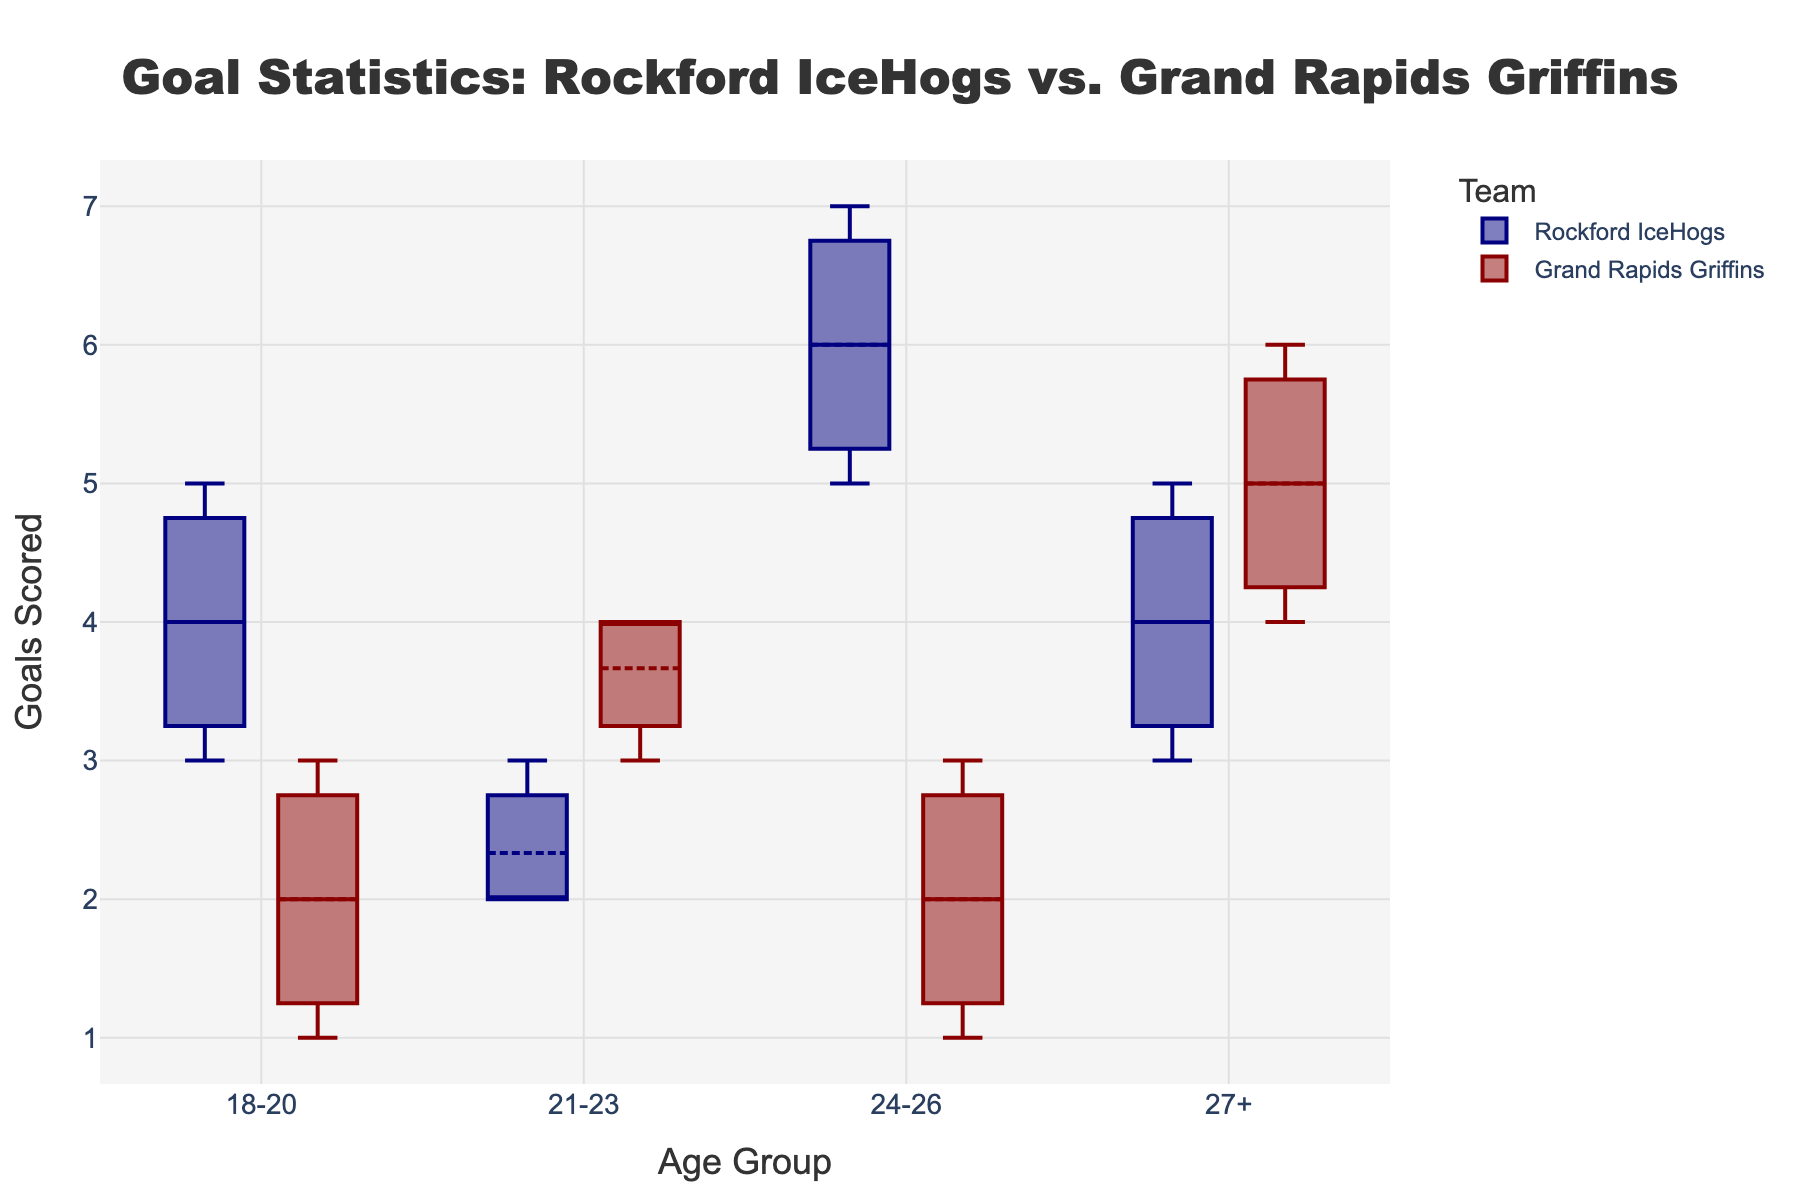What's the title of the figure? The title of the figure is written in a larger font at the top center of the plot.
Answer: Goal Statistics: Rockford IceHogs vs. Grand Rapids Griffins What age groups are shown on the x-axis? The x-axis labels display the different age groups compared.
Answer: 18-20, 21-23, 24-26, 27+ What is the color used to represent Rockford IceHogs' data points? The Rockford IceHogs' data is represented by a specific color in the plot.
Answer: Blue Which age group scored the most goals for Rockford IceHogs? By comparing the median values, we can determine which age group has the highest goal score. The age group 24-26 has the highest median.
Answer: 24-26 How does the median number of goals for the 21-23 age group compare between the two teams? Compare the median line inside the box for the 21-23 age group of both teams. The Rockford IceHogs’ median is below the middle while Grand Rapids Griffins' median is at the center of the boxplot.
Answer: Grand Rapids Griffins have a higher median Which team has more consistent goal-scoring (less variability) in the 18-20 age group? Consistency is shown by the spread of the box in the box plot. A smaller box indicates less variability. The Rockford IceHogs' boxplot for the 18-20 age group is tighter.
Answer: Rockford IceHogs Is there an outlier in the goals scored by any age group? Outliers are often displayed as individual points outside the main box in box plots. We can scan the plot for any such points for all age groups and both teams.
Answer: No outliers Which team has a higher median goal count for the 27+ age group? The median line in the box indicates the median value. For the 27+ age group, the Grand Rapids Griffins have a higher median line compared to the Rockford IceHogs.
Answer: Grand Rapids Griffins What is the interquartile range (IQR) for the 24-26 age group of Rockford IceHogs? The IQR is the range between the first quartile (Q1) and the third quartile (Q3). Calculate IQR by finding the lengths between Q1 and Q3 on the plot for the Rockford IceHogs, visible as the span of the colored boxes.
Answer: 2 (IQR=7-5) How does the goal distribution of the 24-26 age group differ between the two teams? For a compositional question about distributions, compare both the spread and central line (median) of the box plots. The Rockford IceHogs have a more spread-out range of goals and a higher median compared to the more compact distribution of the Grand Rapids Griffins.
Answer: Rockford IceHogs have a higher median and more spread 